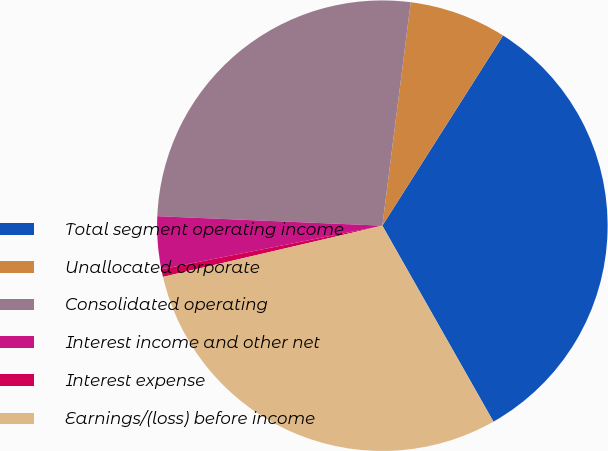Convert chart. <chart><loc_0><loc_0><loc_500><loc_500><pie_chart><fcel>Total segment operating income<fcel>Unallocated corporate<fcel>Consolidated operating<fcel>Interest income and other net<fcel>Interest expense<fcel>Earnings/(loss) before income<nl><fcel>32.79%<fcel>6.99%<fcel>26.34%<fcel>3.77%<fcel>0.55%<fcel>29.56%<nl></chart> 